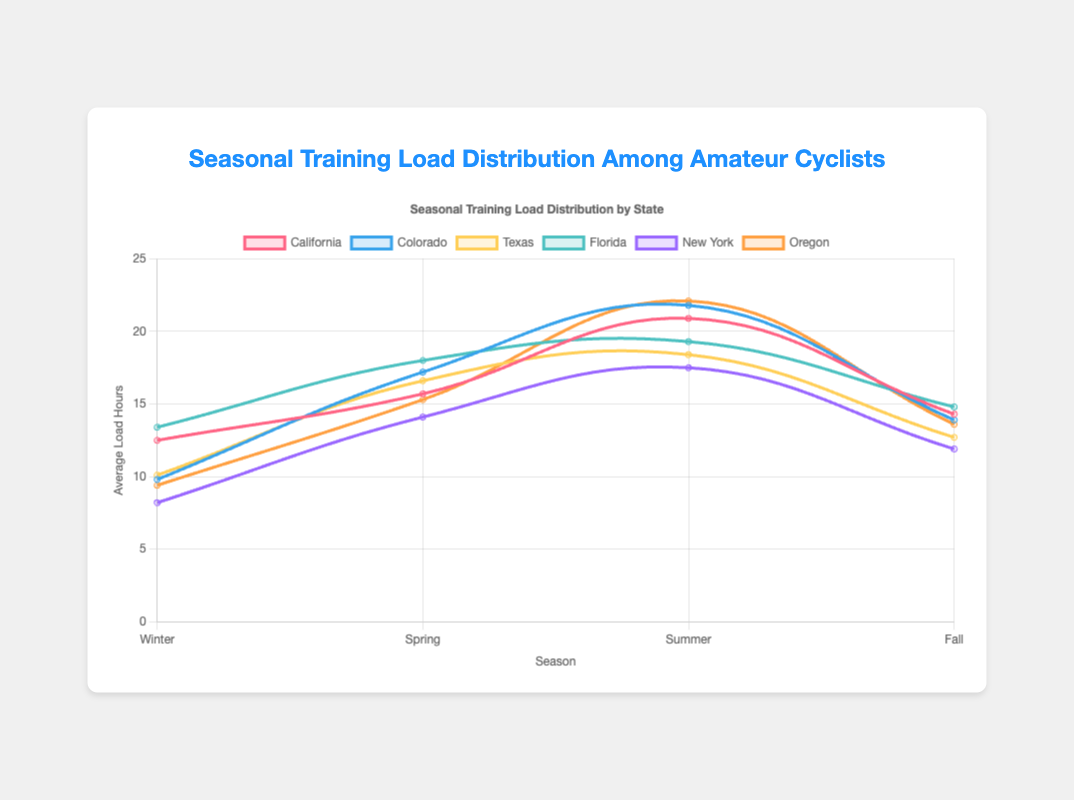Which state has the highest average training load hours in the summer? Look at the plot for the highest peak in the summer segment, which corresponds to the training load hours for that state. The peak value for Oregon in the summer is the highest at 22.1 hours.
Answer: Oregon Which state experiences the lowest average training load hours in winter? Look at the plot to identify the lowest value in the winter segment. The lowest value is for New York at 8.2 hours.
Answer: New York What is the average training load hours for California over all four seasons? Sum the average load hours for each season in California and then divide by the number of seasons: (12.5 + 15.7 + 20.9 + 14.3) / 4 = 63.4 / 4 = 15.85.
Answer: 15.85 Which state shows the greatest increase in average training load hours from winter to summer? Calculate the difference between summer and winter for each state and compare. The difference for Colorado is the greatest: 21.8 - 9.8 = 12 hours.
Answer: Colorado Between Texas and Florida, which state has a higher average training load hours in the fall? Compare the fall training load hours for Texas and Florida. Texas has 12.7 and Florida has 14.8. Hence, Florida has a higher load.
Answer: Florida How does the training load change from spring to fall in New York? Look at the plot to determine the change in values from spring to fall for New York. The value decreases from 14.1 in spring to 11.9 in fall, so it decreases.
Answer: Decreases Which state has the most balanced training load distribution across all seasons (smallest range between highest and lowest load)? Calculate the range for each state by subtracting the lowest value from the highest value and identify the smallest result. Florida has the most balanced distribution: 19.3 - 13.4 = 5.9 hours.
Answer: Florida Which two states have the closest average training load hours in spring? Compare the values for spring across all states and find the two closest values. Texas (16.6) and Oregon (15.3) are closest with a difference of 1.3 hours.
Answer: Texas and Oregon What is the combined training load hours for Oregon in winter and summer? Add the values for Oregon from winter and summer: 9.4 + 22.1 = 31.5 hours.
Answer: 31.5 Which state has a noticeable drop in average training load hours from summer to fall? Look for a significant downward slope from summer to fall on the plot. California shows a noticeable drop from 20.9 in summer to 14.3 in fall.
Answer: California 